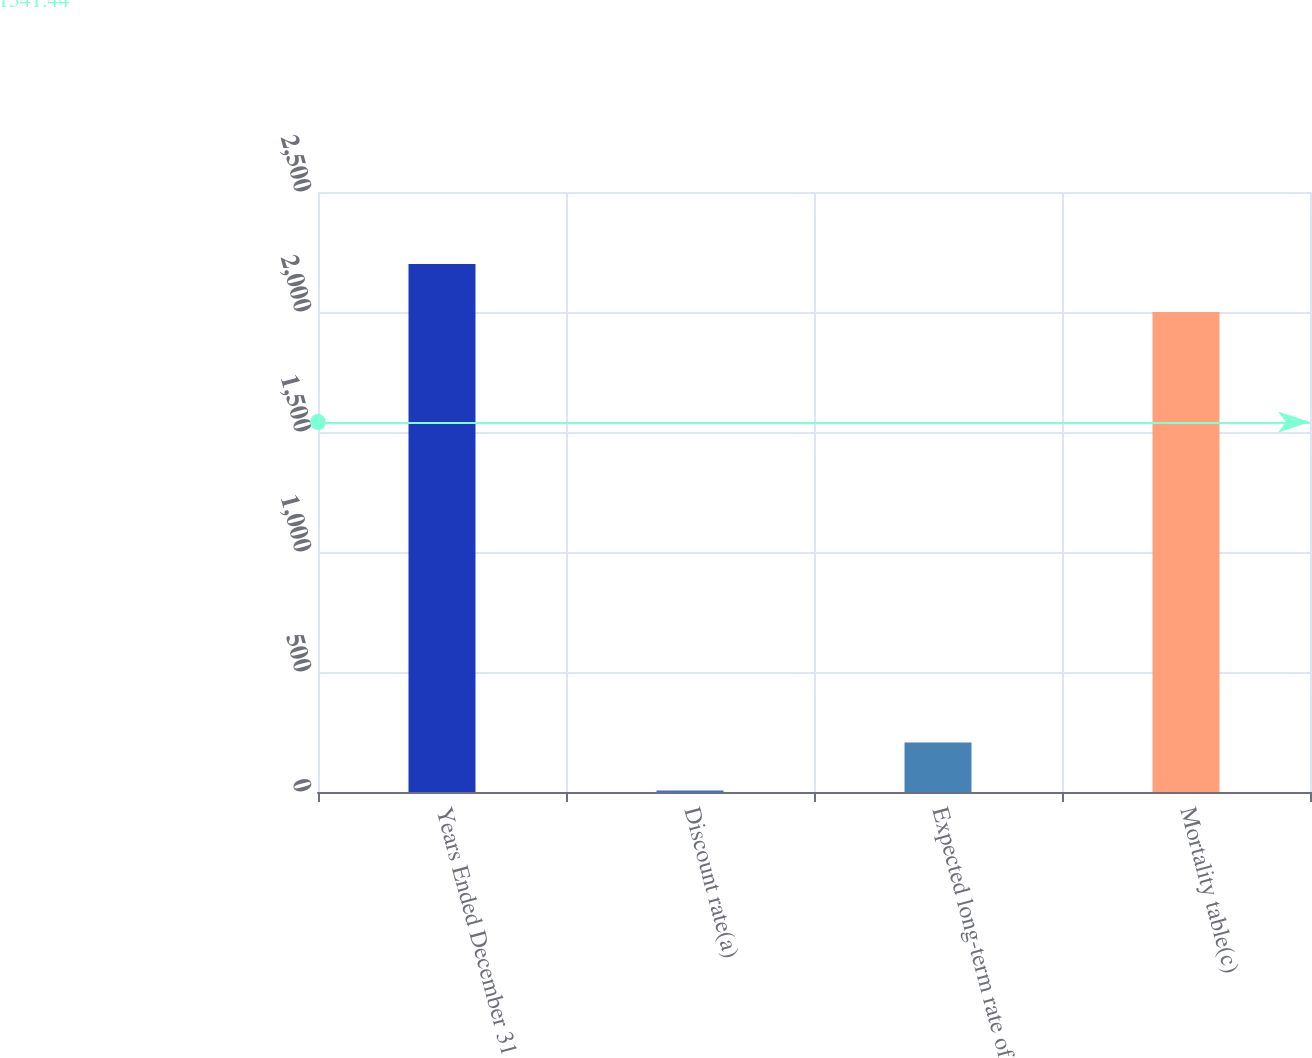<chart> <loc_0><loc_0><loc_500><loc_500><bar_chart><fcel>Years Ended December 31<fcel>Discount rate(a)<fcel>Expected long-term rate of<fcel>Mortality table(c)<nl><fcel>2200.03<fcel>5.75<fcel>205.78<fcel>2000<nl></chart> 